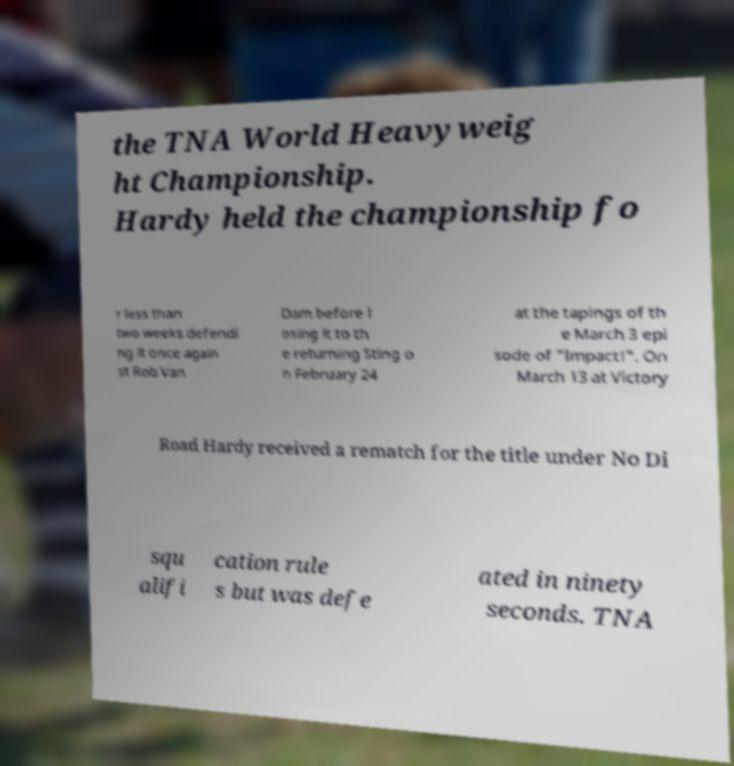Could you extract and type out the text from this image? the TNA World Heavyweig ht Championship. Hardy held the championship fo r less than two weeks defendi ng it once again st Rob Van Dam before l osing it to th e returning Sting o n February 24 at the tapings of th e March 3 epi sode of "Impact!". On March 13 at Victory Road Hardy received a rematch for the title under No Di squ alifi cation rule s but was defe ated in ninety seconds. TNA 